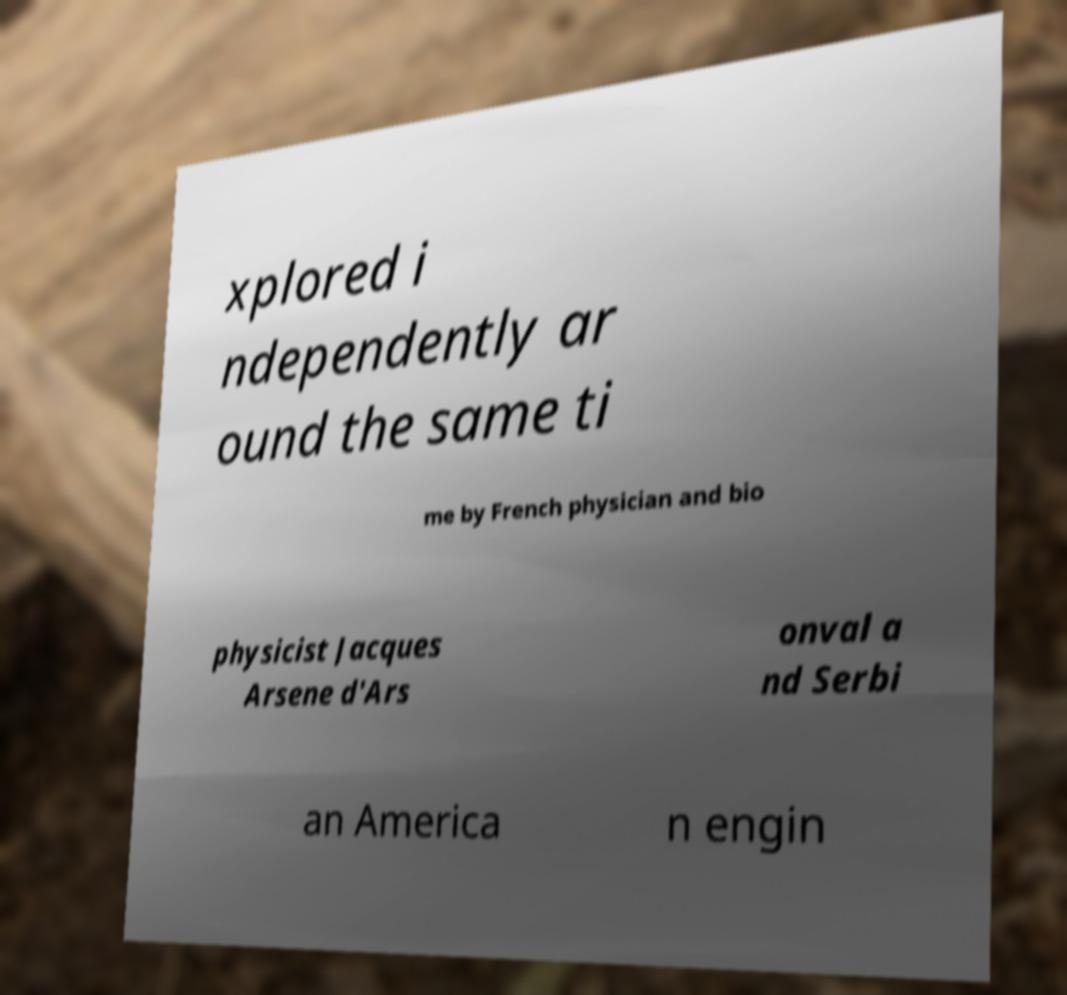Please identify and transcribe the text found in this image. xplored i ndependently ar ound the same ti me by French physician and bio physicist Jacques Arsene d'Ars onval a nd Serbi an America n engin 